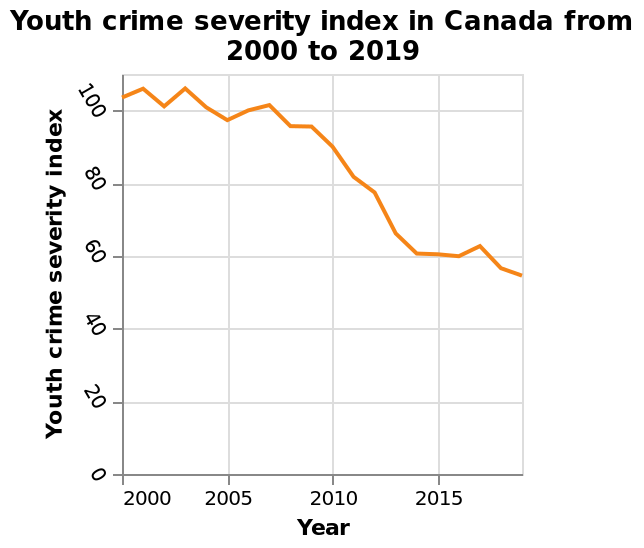<image>
Offer a thorough analysis of the image. Apart from a few minor increases in 2001, 2003, 2005-7 and 2017, there has been a reduction in youth crime severity between 2000 and 2019. The decrease was significant between 2009 and 2014. What is being plotted on the y-axis of the line plot? Youth crime severity index is being plotted on the y-axis. 